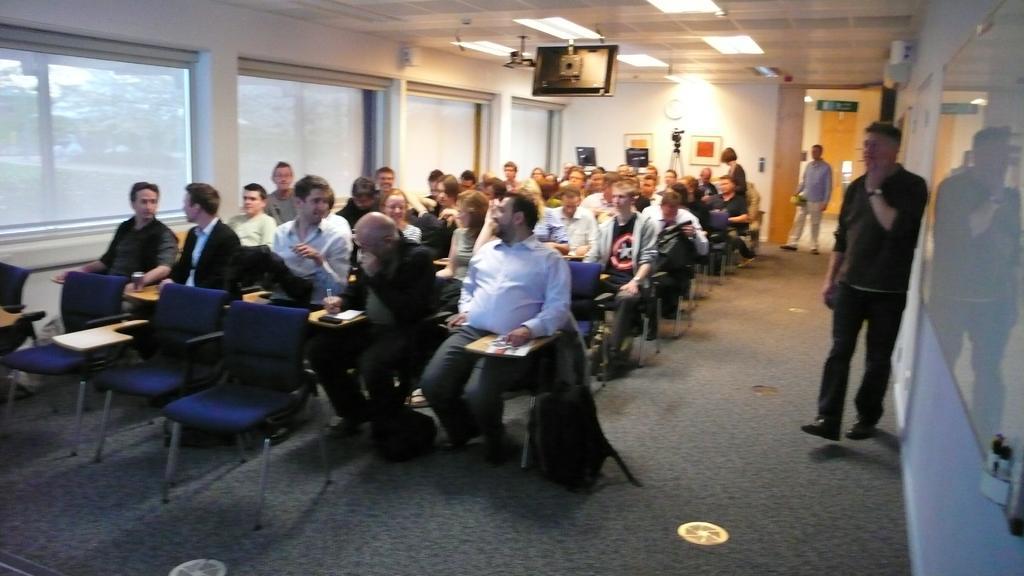Please provide a concise description of this image. In this room we can see people are sitting on the chairs on the floor and two persons are walking and a woman is standing on the right side. On the right there is a board and other objects on the wall. In the background there are two monitors,camera on a stand and a frame on the wall and there is a door and small boards. On the left we can see glass doors and through it we can see trees and sky. On the ceiling we can see lights and a screen. 